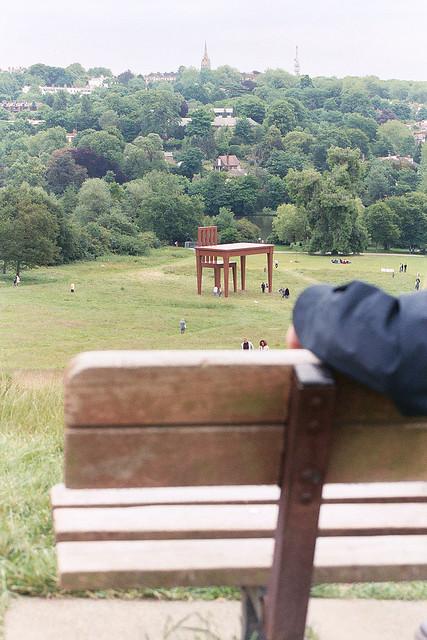Is there a church in the background?
Keep it brief. Yes. Is the brightness of the boards on the bench seat due to the sun shining overhead?
Keep it brief. Yes. What is the center of the picture?
Be succinct. Table and chair. 